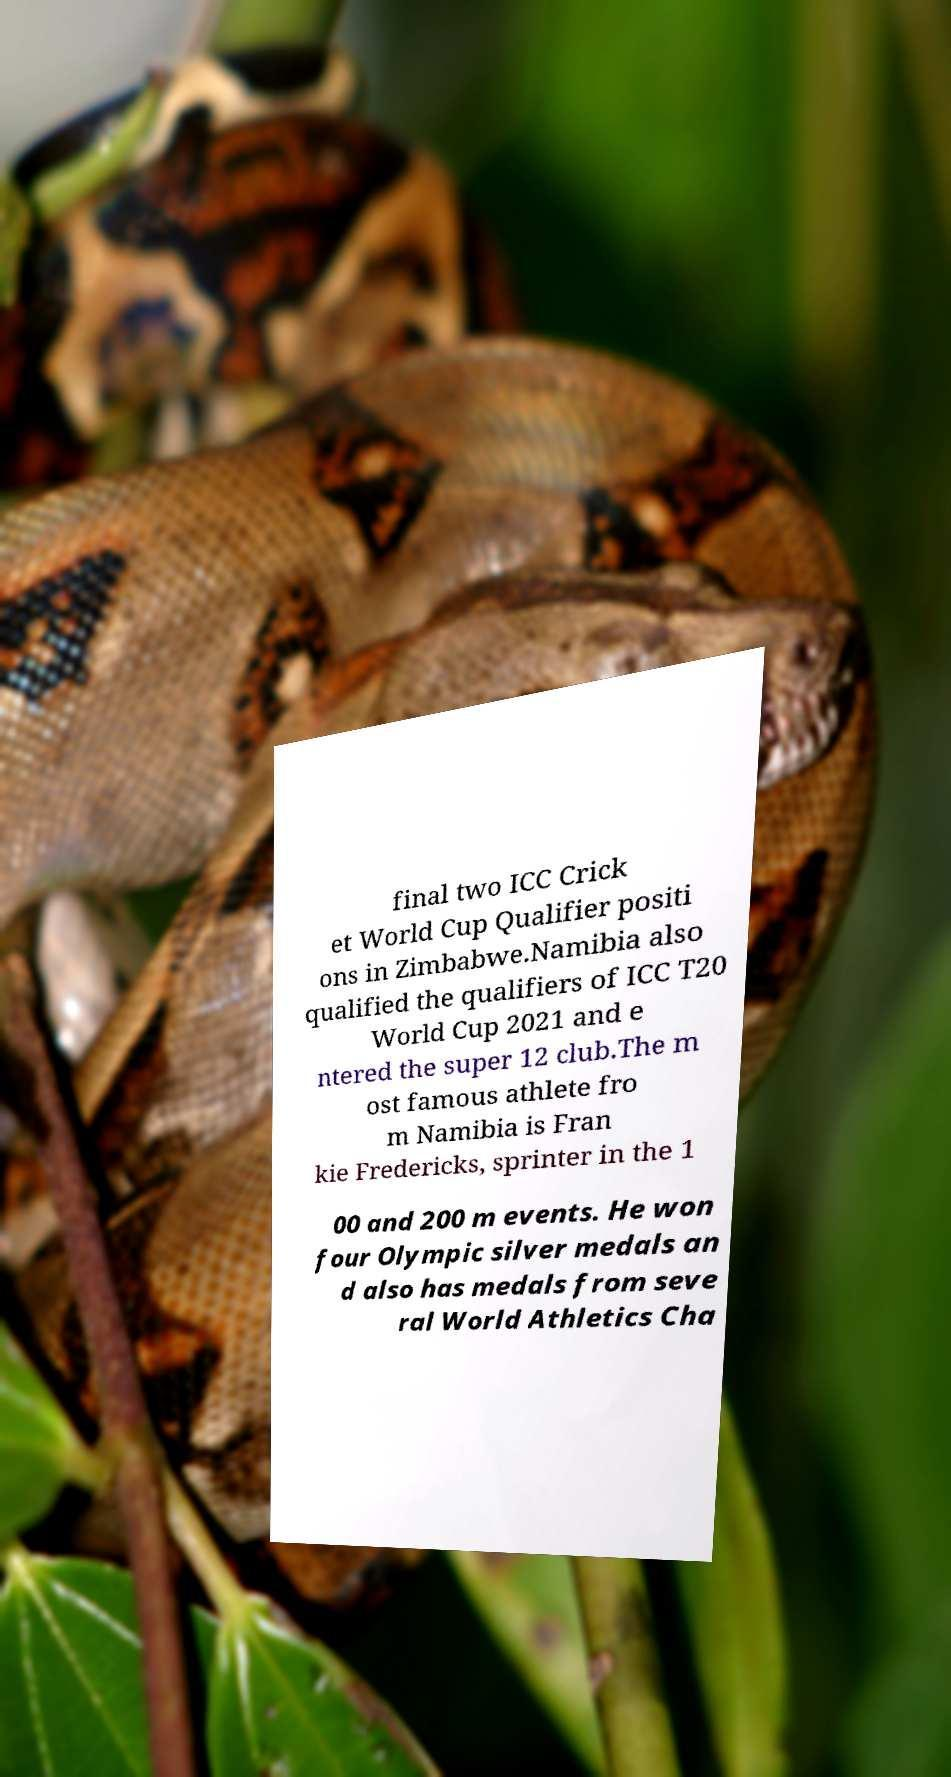Can you read and provide the text displayed in the image?This photo seems to have some interesting text. Can you extract and type it out for me? final two ICC Crick et World Cup Qualifier positi ons in Zimbabwe.Namibia also qualified the qualifiers of ICC T20 World Cup 2021 and e ntered the super 12 club.The m ost famous athlete fro m Namibia is Fran kie Fredericks, sprinter in the 1 00 and 200 m events. He won four Olympic silver medals an d also has medals from seve ral World Athletics Cha 